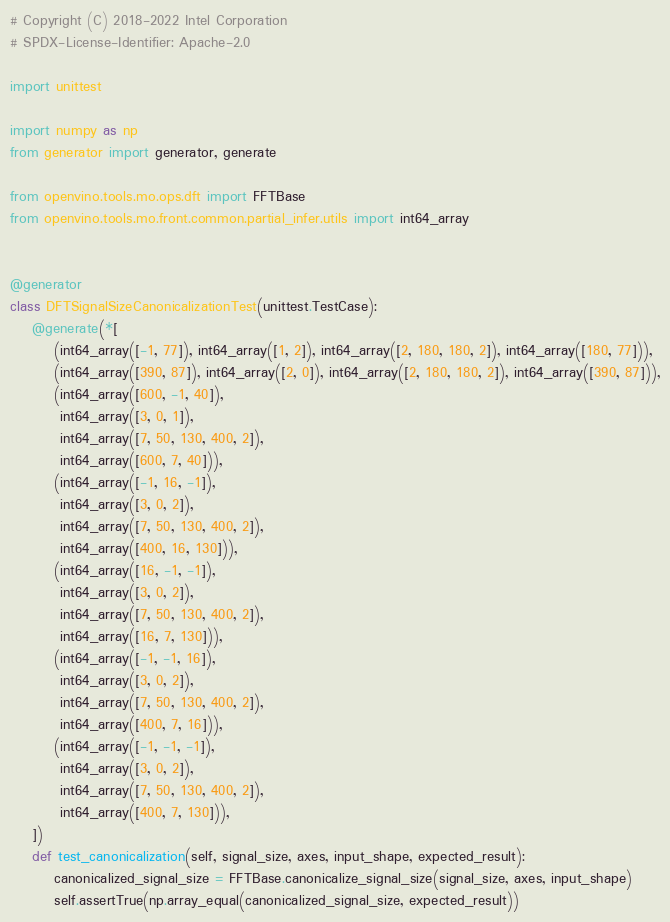<code> <loc_0><loc_0><loc_500><loc_500><_Python_># Copyright (C) 2018-2022 Intel Corporation
# SPDX-License-Identifier: Apache-2.0

import unittest

import numpy as np
from generator import generator, generate

from openvino.tools.mo.ops.dft import FFTBase
from openvino.tools.mo.front.common.partial_infer.utils import int64_array


@generator
class DFTSignalSizeCanonicalizationTest(unittest.TestCase):
    @generate(*[
        (int64_array([-1, 77]), int64_array([1, 2]), int64_array([2, 180, 180, 2]), int64_array([180, 77])),
        (int64_array([390, 87]), int64_array([2, 0]), int64_array([2, 180, 180, 2]), int64_array([390, 87])),
        (int64_array([600, -1, 40]),
         int64_array([3, 0, 1]),
         int64_array([7, 50, 130, 400, 2]),
         int64_array([600, 7, 40])),
        (int64_array([-1, 16, -1]),
         int64_array([3, 0, 2]),
         int64_array([7, 50, 130, 400, 2]),
         int64_array([400, 16, 130])),
        (int64_array([16, -1, -1]),
         int64_array([3, 0, 2]),
         int64_array([7, 50, 130, 400, 2]),
         int64_array([16, 7, 130])),
        (int64_array([-1, -1, 16]),
         int64_array([3, 0, 2]),
         int64_array([7, 50, 130, 400, 2]),
         int64_array([400, 7, 16])),
        (int64_array([-1, -1, -1]),
         int64_array([3, 0, 2]),
         int64_array([7, 50, 130, 400, 2]),
         int64_array([400, 7, 130])),
    ])
    def test_canonicalization(self, signal_size, axes, input_shape, expected_result):
        canonicalized_signal_size = FFTBase.canonicalize_signal_size(signal_size, axes, input_shape)
        self.assertTrue(np.array_equal(canonicalized_signal_size, expected_result))
</code> 